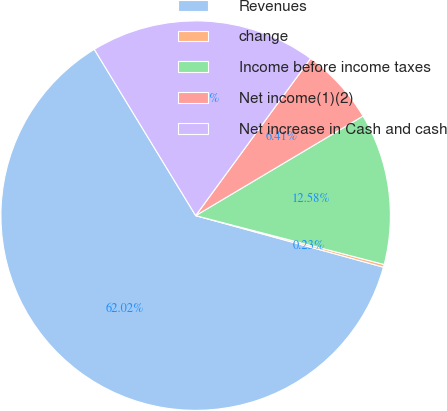Convert chart to OTSL. <chart><loc_0><loc_0><loc_500><loc_500><pie_chart><fcel>Revenues<fcel>change<fcel>Income before income taxes<fcel>Net income(1)(2)<fcel>Net increase in Cash and cash<nl><fcel>62.02%<fcel>0.23%<fcel>12.58%<fcel>6.41%<fcel>18.76%<nl></chart> 